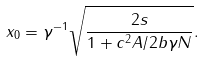<formula> <loc_0><loc_0><loc_500><loc_500>x _ { 0 } = \gamma ^ { - 1 } \sqrt { \frac { 2 s } { 1 + { c ^ { 2 } A / 2 b \gamma N } } } .</formula> 